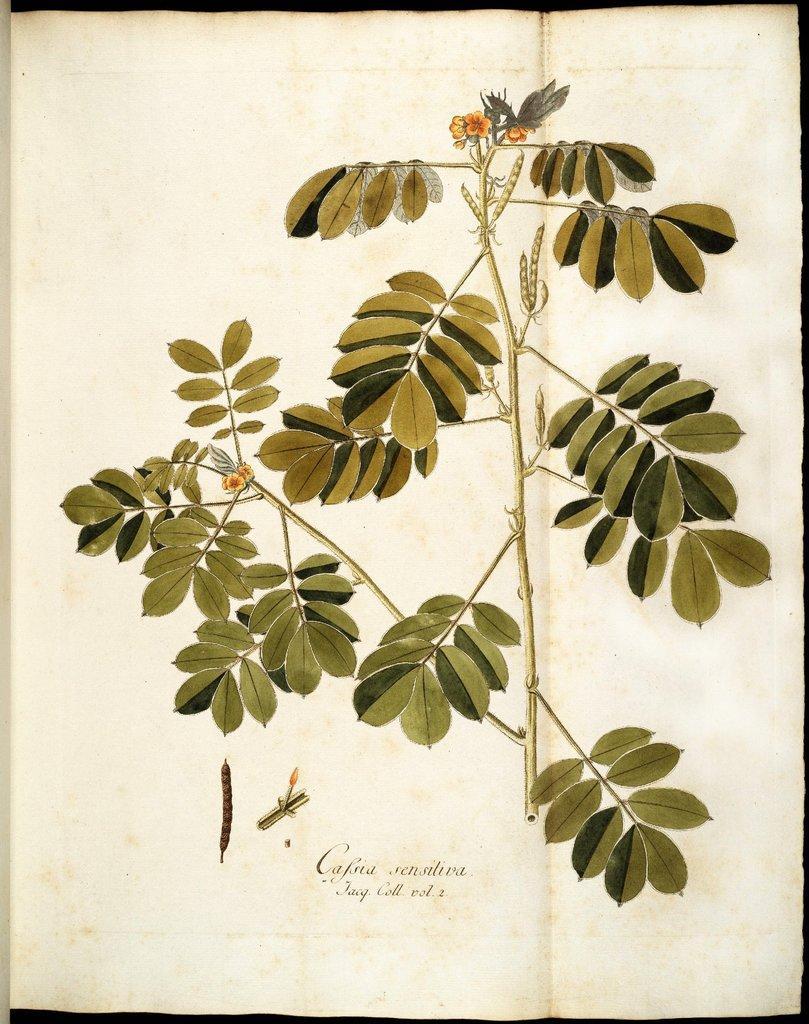How would you summarize this image in a sentence or two? This image consists of a paper with an image of a plant with stems, green leaves, flowers and beans and there is a text on it. 